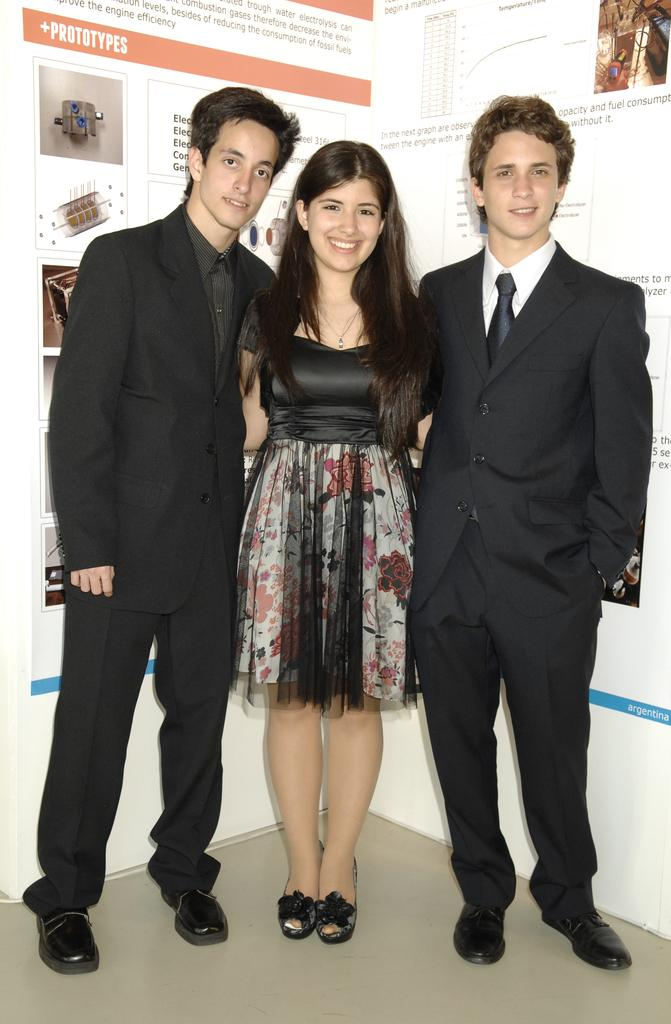How many people are in the image? There are three persons in the image. Can you describe the gender of the people in the image? Two of the persons are men, and one is a woman. What can be seen in the background of the image? There is a wall in the background of the image. What is written or depicted on the wall? There is text on the wall. What is at the bottom of the image? There is a floor at the bottom of the image. What type of sack can be seen hanging from the wall in the image? There is no sack present in the image; only the wall with text is visible. How many clams are visible on the floor in the image? There are no clams present in the image; the floor is not described as having any clams. 